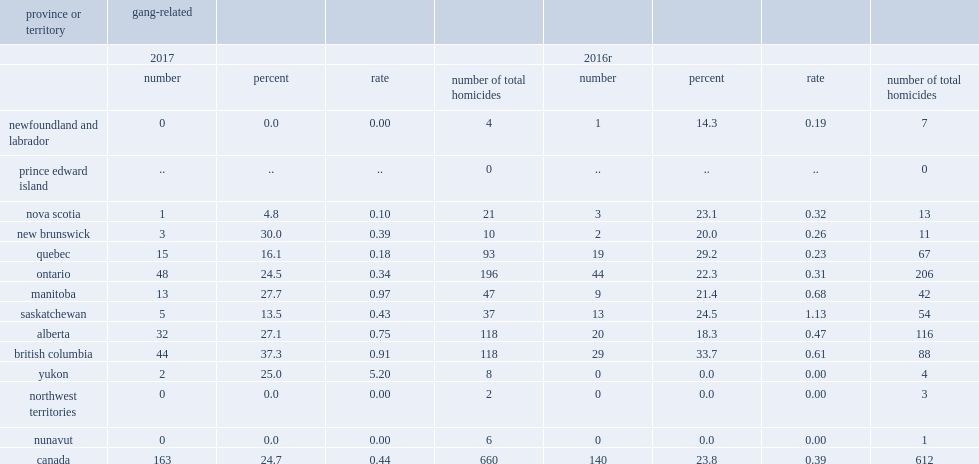In 2017, how many gang-related homicides that occurred in british columbia? 44.0. Of the 37 total homicides in saskatchewan in 2017, what was the percent of homicides were gang-related? 13.5. Of the 37 total homicides in saskatchewan in 2016, what was the percent of homicides were gang-related? 24.5. 